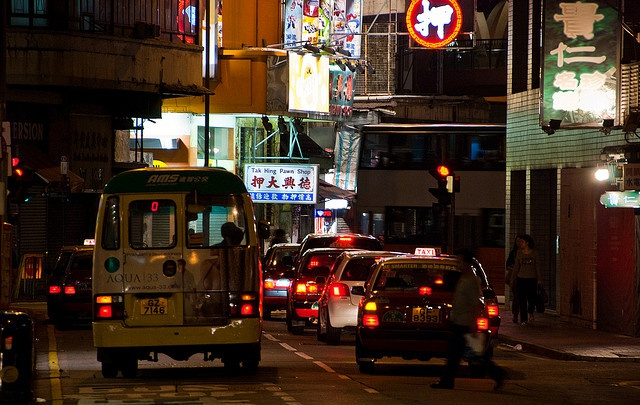Describe the objects in this image and their specific colors. I can see bus in black, maroon, and gray tones, car in black, maroon, red, and white tones, people in black, maroon, and brown tones, car in black, maroon, brown, and tan tones, and car in black, maroon, red, and brown tones in this image. 